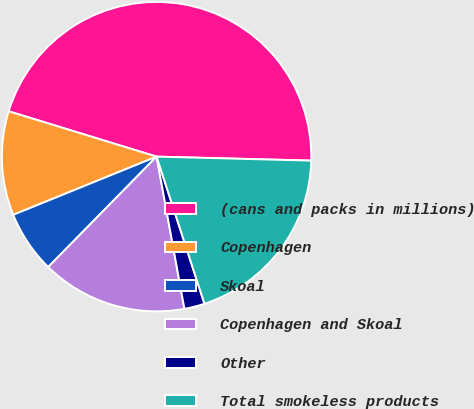<chart> <loc_0><loc_0><loc_500><loc_500><pie_chart><fcel>(cans and packs in millions)<fcel>Copenhagen<fcel>Skoal<fcel>Copenhagen and Skoal<fcel>Other<fcel>Total smokeless products<nl><fcel>45.68%<fcel>10.87%<fcel>6.51%<fcel>15.23%<fcel>2.13%<fcel>19.58%<nl></chart> 